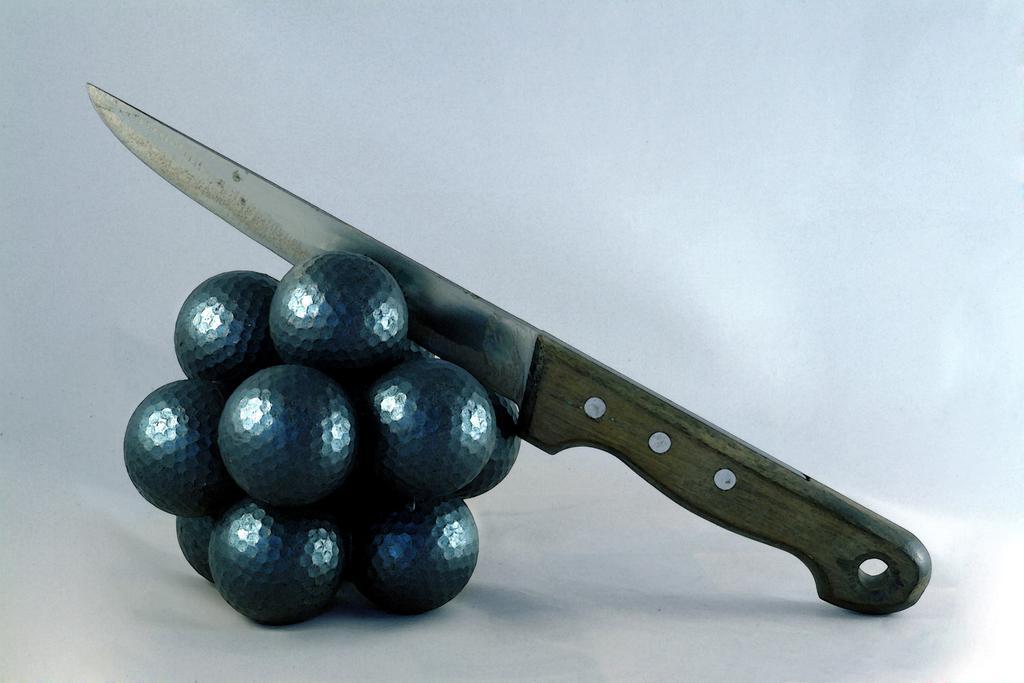Can you describe this image briefly? On the left side, there is a knife placed in the cluster of the artificial grapes. These grapes are placed on a surface. And the background is white in color. 